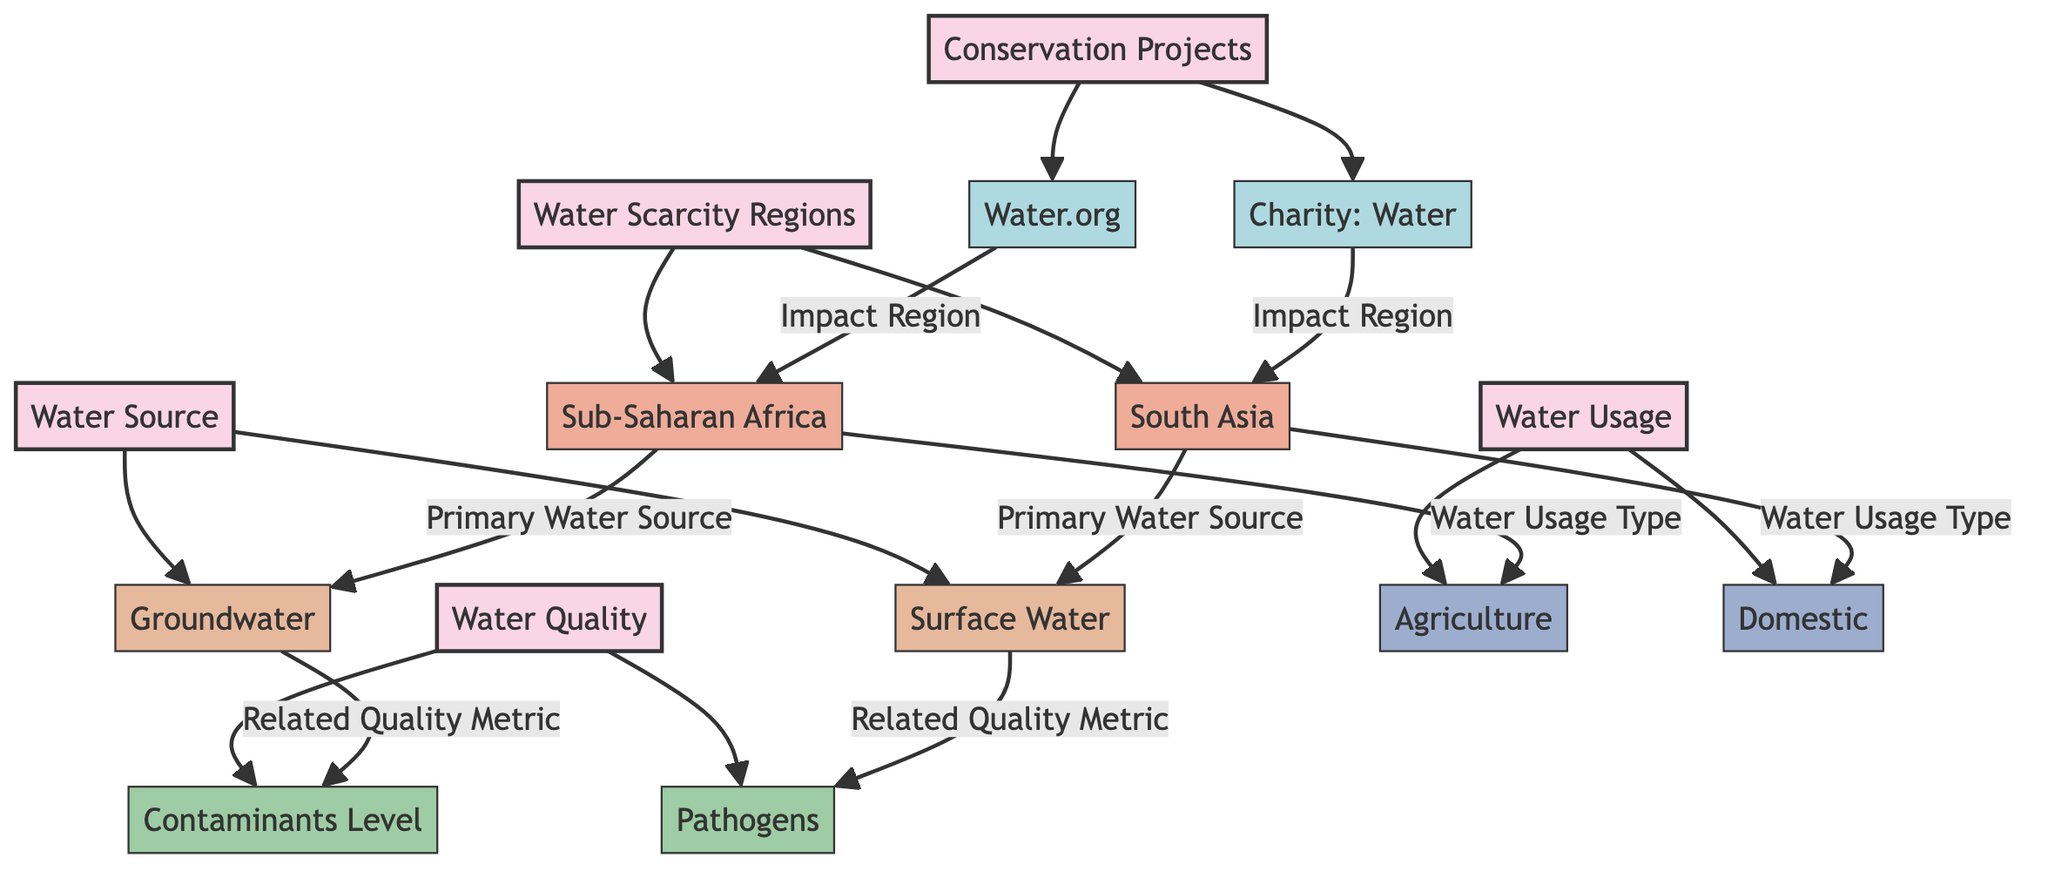What regions are highlighted for water scarcity? The diagram marks two regions under the "Water Scarcity Regions" category: Sub-Saharan Africa and South Asia. These regions are directly linked from the main category node representing water scarcity.
Answer: Sub-Saharan Africa, South Asia What two types of water sources are shown in the diagram? The diagram details two water sources under the "Water Source" category: Groundwater and Surface Water. These sources are listed as child nodes connecting to the primary water source category.
Answer: Groundwater, Surface Water Which non-profits are indicated as contributors to water accessibility? The diagram identifies two non-profits linked to the "Conservation Projects" category: Water.org and Charity: Water. These non-profits are distinct nodes connected to the conservation projects category.
Answer: Water.org, Charity: Water What is the primary water source for Sub-Saharan Africa? The diagram specifies that Groundwater is the primary water source for Sub-Saharan Africa, as indicated by the directed link from the region node to the water source node.
Answer: Groundwater How does water usage in South Asia differ from Sub-Saharan Africa? In the diagram, South Asia is associated with Domestic water usage, while Sub-Saharan Africa is associated with Agriculture usage. This information indicates the different primary purposes for water in these regions.
Answer: Domestic, Agriculture What quality metric is related to Surface Water? The diagram connects the Surface Water source to the Pathogens quality metric, indicating that this metric is a concern for this specific water source type.
Answer: Pathogens What is the relationship between Water.org and Sub-Saharan Africa? The diagram illustrates that Water.org impacts the region of Sub-Saharan Africa, shown by a directed link from the non-profit node to the region node. This establishes a direct association of the non-profit with efforts to enhance water access in that area.
Answer: Impact Region How many quality metrics are listed in the diagram? The diagram includes two quality metrics under the "Water Quality" category: Contaminants Level and Pathogens. These two nodes connected to the water quality category indicate the number of metrics present.
Answer: 2 What type of water usage does the diagram associate with agriculture? The diagram ties Agriculture to Water Usage under the respective category, indicating that it represents one specific type of water usage.
Answer: Agriculture 